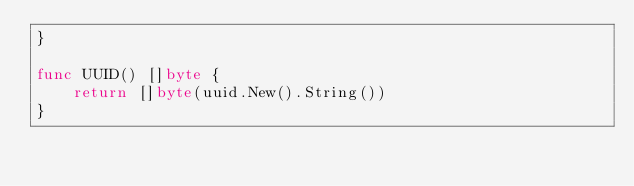Convert code to text. <code><loc_0><loc_0><loc_500><loc_500><_Go_>}

func UUID() []byte {
	return []byte(uuid.New().String())
}
</code> 